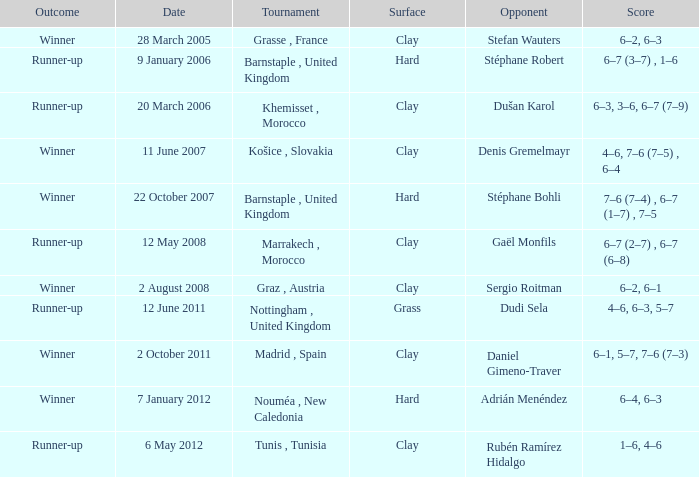Regarding the tournament where dudi sela was the opponent and the outcome was runner-up, what type of surface was it played on? Grass. Help me parse the entirety of this table. {'header': ['Outcome', 'Date', 'Tournament', 'Surface', 'Opponent', 'Score'], 'rows': [['Winner', '28 March 2005', 'Grasse , France', 'Clay', 'Stefan Wauters', '6–2, 6–3'], ['Runner-up', '9 January 2006', 'Barnstaple , United Kingdom', 'Hard', 'Stéphane Robert', '6–7 (3–7) , 1–6'], ['Runner-up', '20 March 2006', 'Khemisset , Morocco', 'Clay', 'Dušan Karol', '6–3, 3–6, 6–7 (7–9)'], ['Winner', '11 June 2007', 'Košice , Slovakia', 'Clay', 'Denis Gremelmayr', '4–6, 7–6 (7–5) , 6–4'], ['Winner', '22 October 2007', 'Barnstaple , United Kingdom', 'Hard', 'Stéphane Bohli', '7–6 (7–4) , 6–7 (1–7) , 7–5'], ['Runner-up', '12 May 2008', 'Marrakech , Morocco', 'Clay', 'Gaël Monfils', '6–7 (2–7) , 6–7 (6–8)'], ['Winner', '2 August 2008', 'Graz , Austria', 'Clay', 'Sergio Roitman', '6–2, 6–1'], ['Runner-up', '12 June 2011', 'Nottingham , United Kingdom', 'Grass', 'Dudi Sela', '4–6, 6–3, 5–7'], ['Winner', '2 October 2011', 'Madrid , Spain', 'Clay', 'Daniel Gimeno-Traver', '6–1, 5–7, 7–6 (7–3)'], ['Winner', '7 January 2012', 'Nouméa , New Caledonia', 'Hard', 'Adrián Menéndez', '6–4, 6–3'], ['Runner-up', '6 May 2012', 'Tunis , Tunisia', 'Clay', 'Rubén Ramírez Hidalgo', '1–6, 4–6']]} 